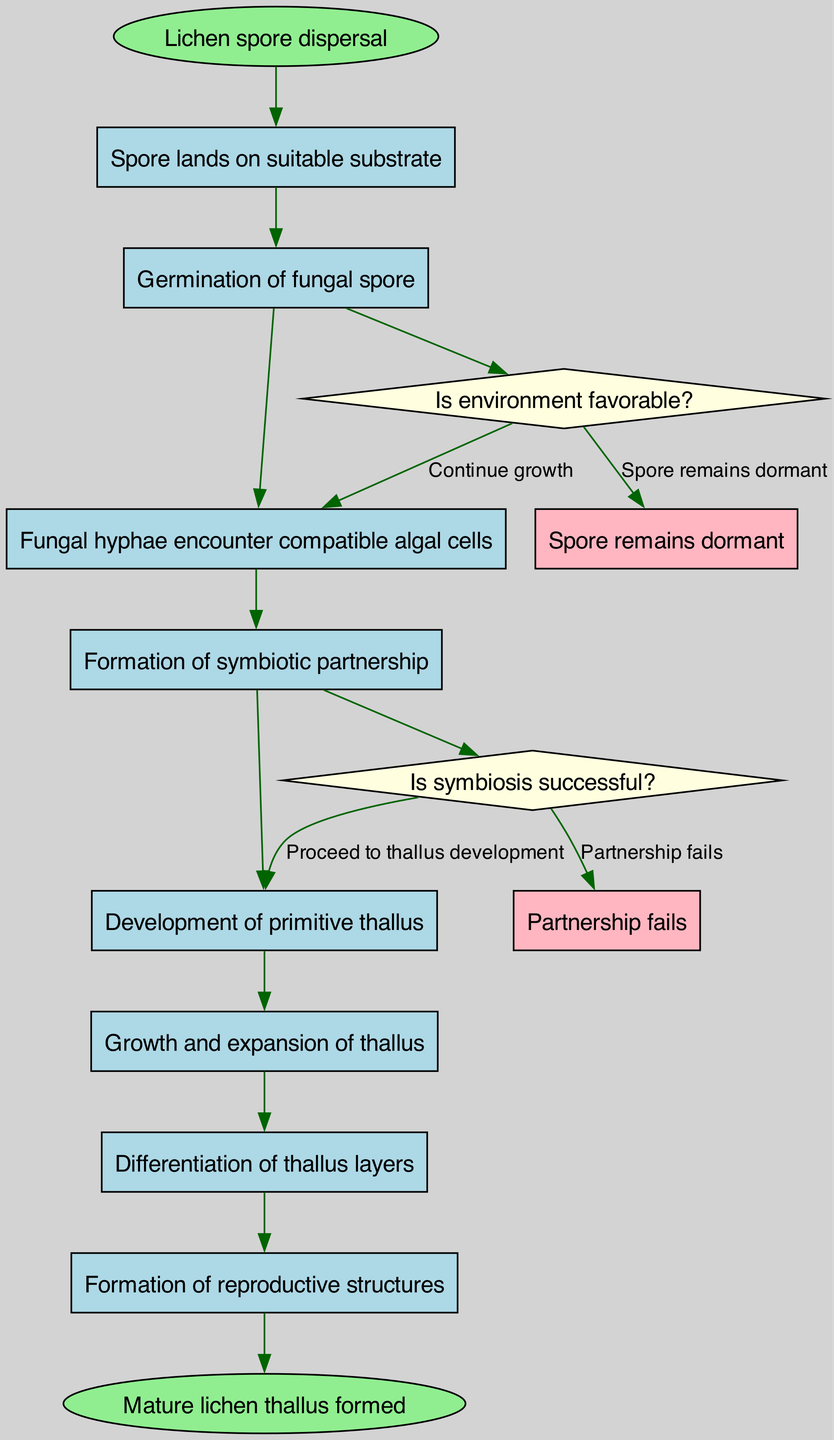What is the starting point of the life cycle? The diagram indicates that the life cycle begins with the node labeled "Lichen spore dispersal," which is the first activity in the flow.
Answer: Lichen spore dispersal How many activities are there in total? There are eight activities listed in the diagram, as seen in the activities section, starting from the spore landing on a suitable substrate to the formation of reproductive structures.
Answer: 8 What decision follows the fungal hyphae encounter? After the activity where fungal hyphae encounter compatible algal cells, the next node is a decision labeled "Is symbiosis successful?" indicating a crucial point in the flow.
Answer: Is symbiosis successful? What happens if the environment is not favorable? If the environment is not favorable, according to the decision labeled "Is environment favorable?", the flow will lead to a failure node labeled "Spore remains dormant," indicating that growth will not continue.
Answer: Spore remains dormant How many edges lead to the end of the diagram? There is only one edge that leads to the "Mature lichen thallus formed" end node, coming from the last activity labeled "Formation of reproductive structures."
Answer: 1 What is the node immediately before the "Development of primitive thallus"? The node immediately before "Development of primitive thallus" is "Formation of symbiotic partnership," indicating the sequence in the development process of the lichen.
Answer: Formation of symbiotic partnership What happens if the partnership fails? If the partnership fails, according to the decision node "Is symbiosis successful?", it leads to the failure node labeled "Partnership fails," indicating a lack of progression in the life cycle.
Answer: Partnership fails What type of node is used for decisions in this diagram? The diagram uses diamond-shaped nodes for decisions, as seen at the points where the diagram asks "Is environment favorable?" and "Is symbiosis successful?" indicating critical decision points in the process.
Answer: Diamond-shaped nodes What activity follows the "Germination of fungal spore"? The activity that follows "Germination of fungal spore" is "Fungal hyphae encounter compatible algal cells," showing the sequential steps in the life cycle.
Answer: Fungal hyphae encounter compatible algal cells 